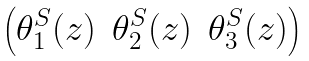<formula> <loc_0><loc_0><loc_500><loc_500>\begin{pmatrix} \theta _ { 1 } ^ { S } ( z ) & \theta _ { 2 } ^ { S } ( z ) & \theta _ { 3 } ^ { S } ( z ) \end{pmatrix}</formula> 